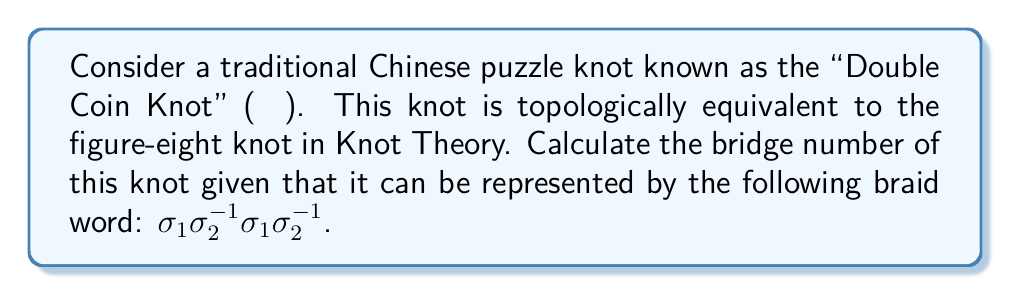Give your solution to this math problem. To compute the bridge number of the Double Coin Knot (figure-eight knot), we'll follow these steps:

1. Recall that the bridge number of a knot is the minimum number of bridges needed in any bridge presentation of the knot.

2. For alternating knots (which the figure-eight knot is), the bridge number is related to the crossing number by the formula:

   $$ \text{bridge number} = \left\lceil\frac{\text{crossing number}}{2}\right\rceil $$

   where $\lceil \cdot \rceil$ denotes the ceiling function.

3. The given braid word $\sigma_1 \sigma_2^{-1} \sigma_1 \sigma_2^{-1}$ represents the figure-eight knot.

4. Count the number of $\sigma$ terms in the braid word to determine the crossing number:
   
   $\sigma_1 \sigma_2^{-1} \sigma_1 \sigma_2^{-1}$ has 4 terms, so the crossing number is 4.

5. Apply the formula:

   $$ \text{bridge number} = \left\lceil\frac{4}{2}\right\rceil = \lceil 2 \rceil = 2 $$

6. Therefore, the bridge number of the Double Coin Knot (figure-eight knot) is 2.

This result aligns with the known fact that the figure-eight knot has a bridge number of 2, which is the smallest possible bridge number for a non-trivial knot.
Answer: 2 